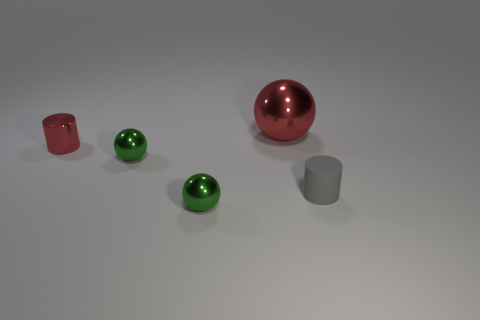Subtract all small metallic balls. How many balls are left? 1 Subtract all yellow cylinders. How many green balls are left? 2 Add 3 tiny gray rubber cylinders. How many objects exist? 8 Subtract all cylinders. How many objects are left? 3 Subtract 1 cylinders. How many cylinders are left? 1 Subtract all brown spheres. Subtract all blue cylinders. How many spheres are left? 3 Add 1 gray rubber things. How many gray rubber things exist? 2 Subtract 0 brown blocks. How many objects are left? 5 Subtract all purple matte cylinders. Subtract all large red metallic spheres. How many objects are left? 4 Add 2 big metal objects. How many big metal objects are left? 3 